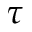Convert formula to latex. <formula><loc_0><loc_0><loc_500><loc_500>\tau</formula> 